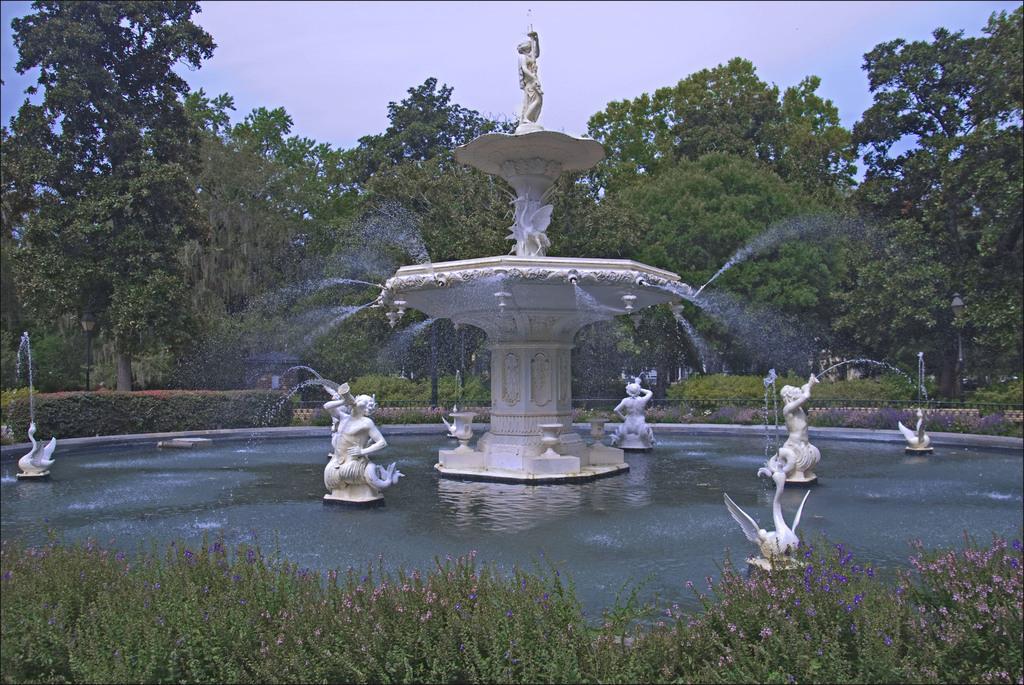Can you describe this image briefly? In the picture we can see a fountain and in the water we can see some sculptures, which are white in color in the water and around the fountain we can see plants with flowers and in the background we can see trees and sky. 